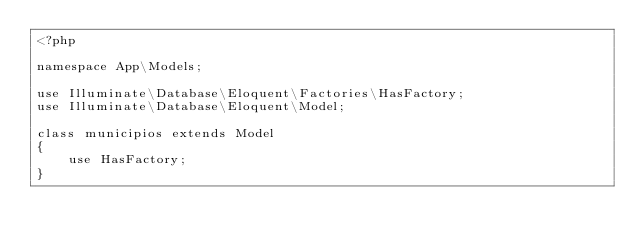Convert code to text. <code><loc_0><loc_0><loc_500><loc_500><_PHP_><?php

namespace App\Models;

use Illuminate\Database\Eloquent\Factories\HasFactory;
use Illuminate\Database\Eloquent\Model;

class municipios extends Model
{
    use HasFactory;
}
</code> 